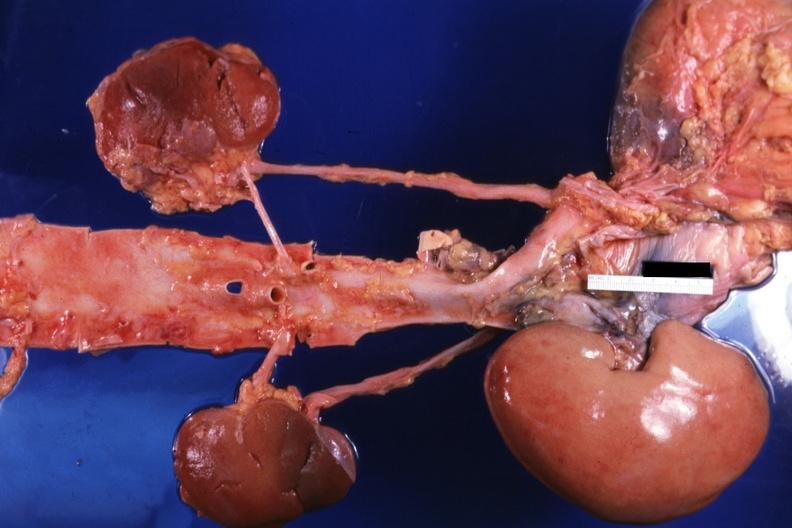how is the transplant placed relative to structures?
Answer the question using a single word or phrase. Other 